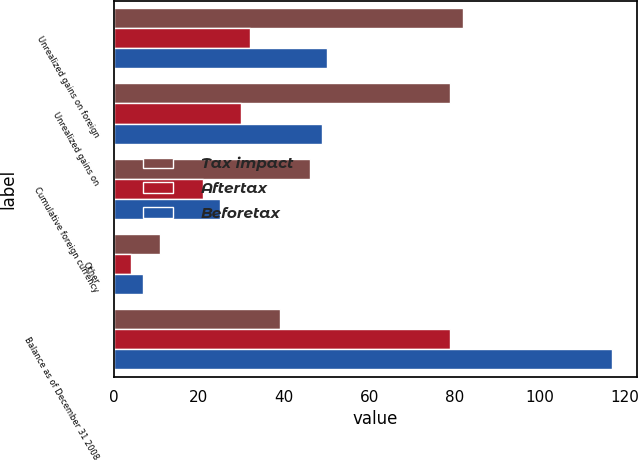Convert chart to OTSL. <chart><loc_0><loc_0><loc_500><loc_500><stacked_bar_chart><ecel><fcel>Unrealized gains on foreign<fcel>Unrealized gains on<fcel>Cumulative foreign currency<fcel>Other<fcel>Balance as of December 31 2008<nl><fcel>Tax impact<fcel>82<fcel>79<fcel>46<fcel>11<fcel>39<nl><fcel>Aftertax<fcel>32<fcel>30<fcel>21<fcel>4<fcel>79<nl><fcel>Beforetax<fcel>50<fcel>49<fcel>25<fcel>7<fcel>117<nl></chart> 